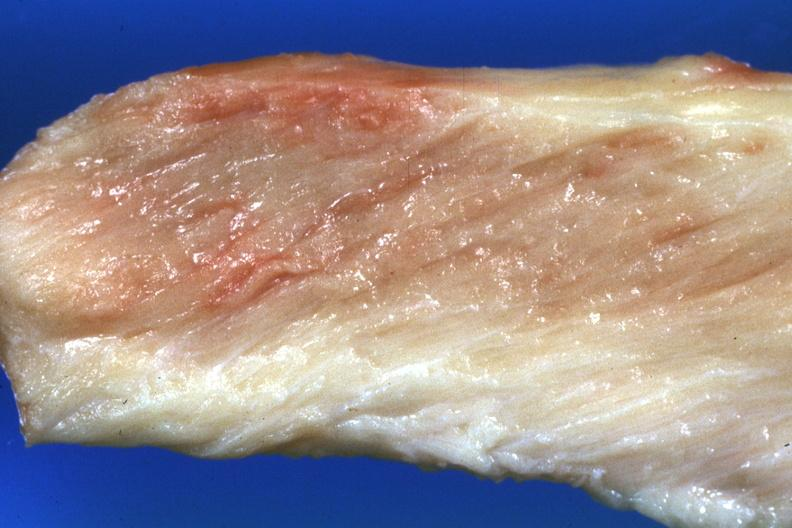do close-up view pale muscle?
Answer the question using a single word or phrase. Yes 